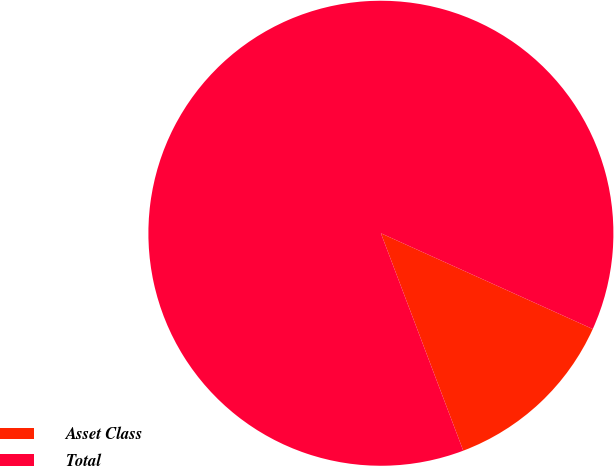<chart> <loc_0><loc_0><loc_500><loc_500><pie_chart><fcel>Asset Class<fcel>Total<nl><fcel>12.48%<fcel>87.52%<nl></chart> 